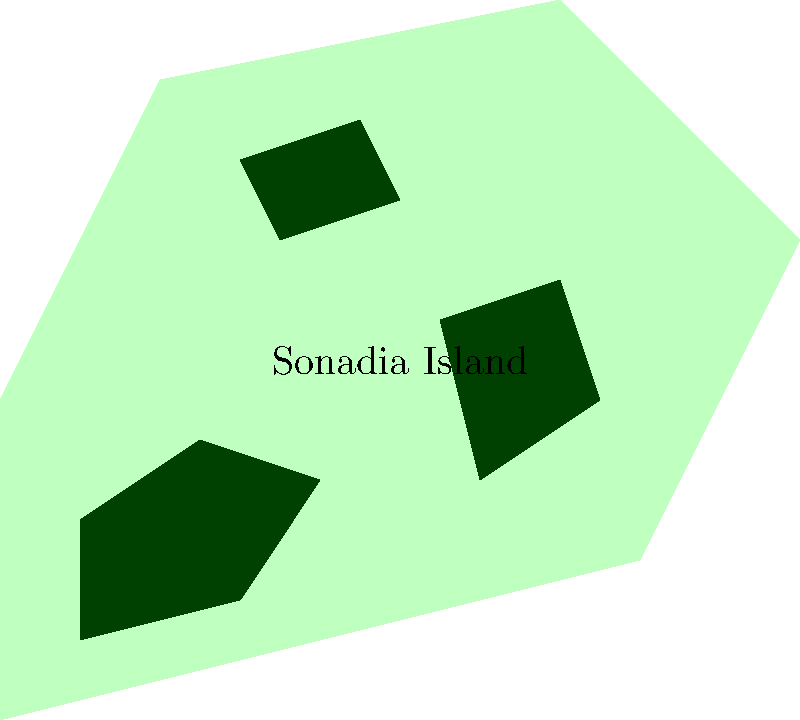Based on the map of Sonadia Island, which area of the island appears to have the highest concentration of mangrove forests? To answer this question, we need to analyze the distribution of mangrove forests on Sonadia Island as shown in the map. Let's break it down step by step:

1. The map shows Sonadia Island with three distinct areas of mangrove forests, represented by dark green patches.

2. We need to compare the size and distribution of these mangrove areas:
   a) There's a mangrove forest in the northwestern part of the island.
   b) Another mangrove forest is located in the eastern part of the island.
   c) A third mangrove forest is situated in the central-northern area.

3. Comparing the sizes:
   - The northwestern mangrove forest appears to be the largest in area.
   - The eastern mangrove forest is slightly smaller.
   - The central-northern mangrove forest is the smallest of the three.

4. Considering the concentration:
   - The northwestern area not only has the largest mangrove forest but also covers a significant portion of that part of the island.
   - The other two mangrove forests, while present, occupy relatively smaller areas in their respective parts of the island.

5. Based on this analysis, we can conclude that the northwestern part of Sonadia Island has the highest concentration of mangrove forests, as it has the largest area covered by mangroves relative to its portion of the island.
Answer: Northwestern part 